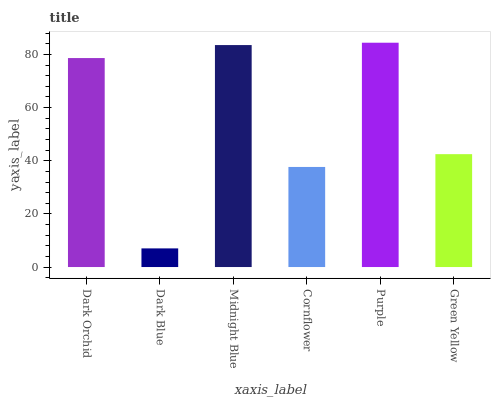Is Dark Blue the minimum?
Answer yes or no. Yes. Is Purple the maximum?
Answer yes or no. Yes. Is Midnight Blue the minimum?
Answer yes or no. No. Is Midnight Blue the maximum?
Answer yes or no. No. Is Midnight Blue greater than Dark Blue?
Answer yes or no. Yes. Is Dark Blue less than Midnight Blue?
Answer yes or no. Yes. Is Dark Blue greater than Midnight Blue?
Answer yes or no. No. Is Midnight Blue less than Dark Blue?
Answer yes or no. No. Is Dark Orchid the high median?
Answer yes or no. Yes. Is Green Yellow the low median?
Answer yes or no. Yes. Is Cornflower the high median?
Answer yes or no. No. Is Cornflower the low median?
Answer yes or no. No. 